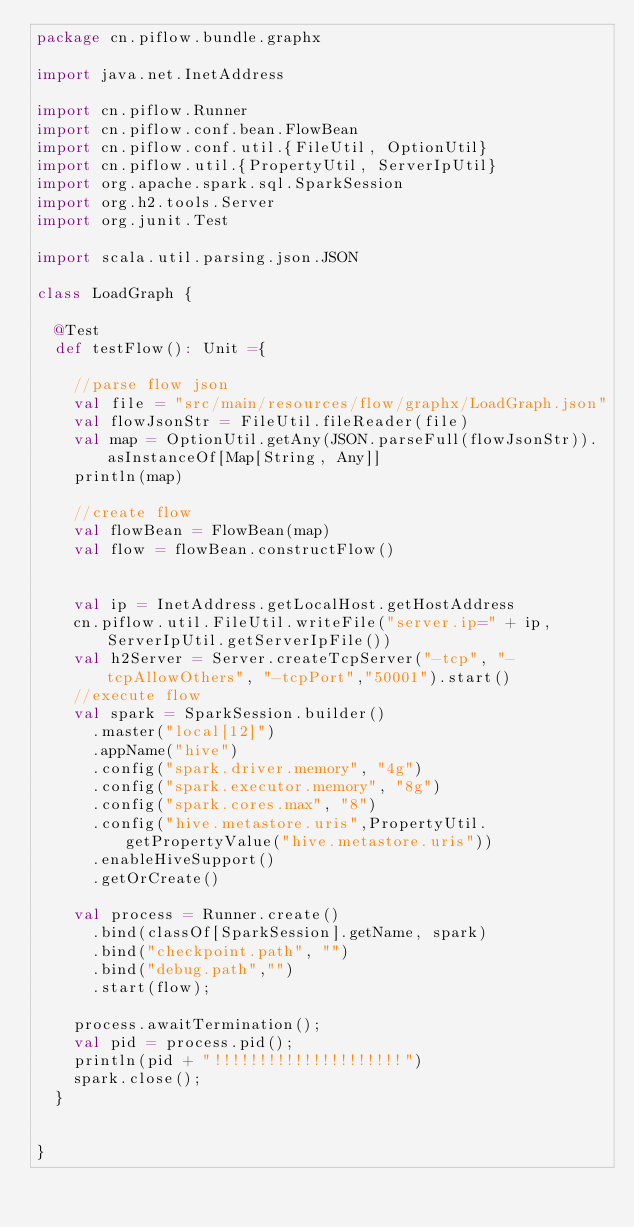Convert code to text. <code><loc_0><loc_0><loc_500><loc_500><_Scala_>package cn.piflow.bundle.graphx

import java.net.InetAddress

import cn.piflow.Runner
import cn.piflow.conf.bean.FlowBean
import cn.piflow.conf.util.{FileUtil, OptionUtil}
import cn.piflow.util.{PropertyUtil, ServerIpUtil}
import org.apache.spark.sql.SparkSession
import org.h2.tools.Server
import org.junit.Test

import scala.util.parsing.json.JSON

class LoadGraph {

  @Test
  def testFlow(): Unit ={

    //parse flow json
    val file = "src/main/resources/flow/graphx/LoadGraph.json"
    val flowJsonStr = FileUtil.fileReader(file)
    val map = OptionUtil.getAny(JSON.parseFull(flowJsonStr)).asInstanceOf[Map[String, Any]]
    println(map)

    //create flow
    val flowBean = FlowBean(map)
    val flow = flowBean.constructFlow()


    val ip = InetAddress.getLocalHost.getHostAddress
    cn.piflow.util.FileUtil.writeFile("server.ip=" + ip, ServerIpUtil.getServerIpFile())
    val h2Server = Server.createTcpServer("-tcp", "-tcpAllowOthers", "-tcpPort","50001").start()
    //execute flow
    val spark = SparkSession.builder()
      .master("local[12]")
      .appName("hive")
      .config("spark.driver.memory", "4g")
      .config("spark.executor.memory", "8g")
      .config("spark.cores.max", "8")
      .config("hive.metastore.uris",PropertyUtil.getPropertyValue("hive.metastore.uris"))
      .enableHiveSupport()
      .getOrCreate()

    val process = Runner.create()
      .bind(classOf[SparkSession].getName, spark)
      .bind("checkpoint.path", "")
      .bind("debug.path","")
      .start(flow);

    process.awaitTermination();
    val pid = process.pid();
    println(pid + "!!!!!!!!!!!!!!!!!!!!!")
    spark.close();
  }


}
</code> 